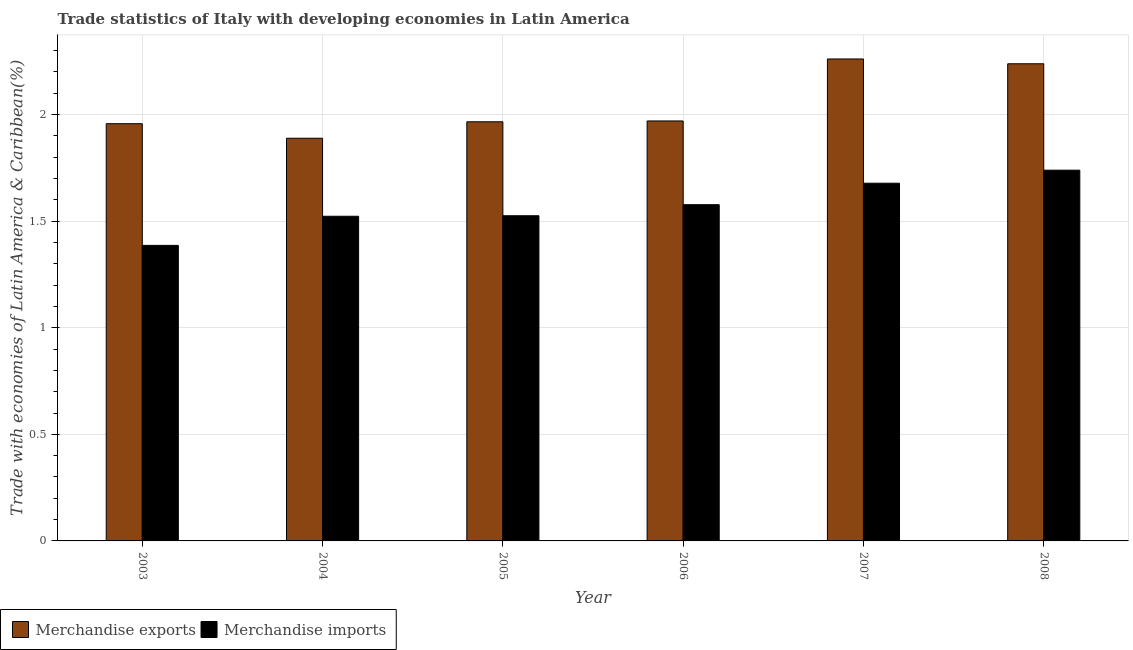How many different coloured bars are there?
Make the answer very short. 2. How many groups of bars are there?
Your response must be concise. 6. Are the number of bars on each tick of the X-axis equal?
Your response must be concise. Yes. How many bars are there on the 6th tick from the left?
Give a very brief answer. 2. What is the label of the 3rd group of bars from the left?
Keep it short and to the point. 2005. In how many cases, is the number of bars for a given year not equal to the number of legend labels?
Offer a terse response. 0. What is the merchandise exports in 2006?
Provide a short and direct response. 1.97. Across all years, what is the maximum merchandise exports?
Provide a short and direct response. 2.26. Across all years, what is the minimum merchandise imports?
Ensure brevity in your answer.  1.39. In which year was the merchandise imports minimum?
Provide a short and direct response. 2003. What is the total merchandise imports in the graph?
Make the answer very short. 9.43. What is the difference between the merchandise exports in 2003 and that in 2005?
Keep it short and to the point. -0.01. What is the difference between the merchandise exports in 2006 and the merchandise imports in 2007?
Provide a short and direct response. -0.29. What is the average merchandise exports per year?
Offer a very short reply. 2.05. In the year 2007, what is the difference between the merchandise exports and merchandise imports?
Provide a short and direct response. 0. What is the ratio of the merchandise imports in 2003 to that in 2004?
Provide a succinct answer. 0.91. Is the merchandise exports in 2003 less than that in 2008?
Offer a terse response. Yes. Is the difference between the merchandise exports in 2007 and 2008 greater than the difference between the merchandise imports in 2007 and 2008?
Offer a terse response. No. What is the difference between the highest and the second highest merchandise imports?
Offer a very short reply. 0.06. What is the difference between the highest and the lowest merchandise imports?
Keep it short and to the point. 0.35. Is the sum of the merchandise exports in 2004 and 2007 greater than the maximum merchandise imports across all years?
Make the answer very short. Yes. How many years are there in the graph?
Offer a very short reply. 6. Does the graph contain grids?
Your answer should be compact. Yes. How many legend labels are there?
Offer a terse response. 2. What is the title of the graph?
Provide a succinct answer. Trade statistics of Italy with developing economies in Latin America. What is the label or title of the X-axis?
Your answer should be compact. Year. What is the label or title of the Y-axis?
Give a very brief answer. Trade with economies of Latin America & Caribbean(%). What is the Trade with economies of Latin America & Caribbean(%) in Merchandise exports in 2003?
Keep it short and to the point. 1.96. What is the Trade with economies of Latin America & Caribbean(%) in Merchandise imports in 2003?
Your answer should be compact. 1.39. What is the Trade with economies of Latin America & Caribbean(%) in Merchandise exports in 2004?
Make the answer very short. 1.89. What is the Trade with economies of Latin America & Caribbean(%) of Merchandise imports in 2004?
Your response must be concise. 1.52. What is the Trade with economies of Latin America & Caribbean(%) in Merchandise exports in 2005?
Make the answer very short. 1.97. What is the Trade with economies of Latin America & Caribbean(%) of Merchandise imports in 2005?
Provide a short and direct response. 1.53. What is the Trade with economies of Latin America & Caribbean(%) in Merchandise exports in 2006?
Provide a short and direct response. 1.97. What is the Trade with economies of Latin America & Caribbean(%) in Merchandise imports in 2006?
Provide a succinct answer. 1.58. What is the Trade with economies of Latin America & Caribbean(%) in Merchandise exports in 2007?
Provide a short and direct response. 2.26. What is the Trade with economies of Latin America & Caribbean(%) of Merchandise imports in 2007?
Your response must be concise. 1.68. What is the Trade with economies of Latin America & Caribbean(%) of Merchandise exports in 2008?
Make the answer very short. 2.24. What is the Trade with economies of Latin America & Caribbean(%) of Merchandise imports in 2008?
Provide a short and direct response. 1.74. Across all years, what is the maximum Trade with economies of Latin America & Caribbean(%) in Merchandise exports?
Your response must be concise. 2.26. Across all years, what is the maximum Trade with economies of Latin America & Caribbean(%) in Merchandise imports?
Offer a terse response. 1.74. Across all years, what is the minimum Trade with economies of Latin America & Caribbean(%) in Merchandise exports?
Provide a succinct answer. 1.89. Across all years, what is the minimum Trade with economies of Latin America & Caribbean(%) of Merchandise imports?
Your response must be concise. 1.39. What is the total Trade with economies of Latin America & Caribbean(%) of Merchandise exports in the graph?
Give a very brief answer. 12.28. What is the total Trade with economies of Latin America & Caribbean(%) of Merchandise imports in the graph?
Offer a terse response. 9.43. What is the difference between the Trade with economies of Latin America & Caribbean(%) of Merchandise exports in 2003 and that in 2004?
Provide a short and direct response. 0.07. What is the difference between the Trade with economies of Latin America & Caribbean(%) in Merchandise imports in 2003 and that in 2004?
Keep it short and to the point. -0.14. What is the difference between the Trade with economies of Latin America & Caribbean(%) of Merchandise exports in 2003 and that in 2005?
Keep it short and to the point. -0.01. What is the difference between the Trade with economies of Latin America & Caribbean(%) of Merchandise imports in 2003 and that in 2005?
Offer a very short reply. -0.14. What is the difference between the Trade with economies of Latin America & Caribbean(%) in Merchandise exports in 2003 and that in 2006?
Provide a succinct answer. -0.01. What is the difference between the Trade with economies of Latin America & Caribbean(%) in Merchandise imports in 2003 and that in 2006?
Provide a short and direct response. -0.19. What is the difference between the Trade with economies of Latin America & Caribbean(%) of Merchandise exports in 2003 and that in 2007?
Your answer should be compact. -0.3. What is the difference between the Trade with economies of Latin America & Caribbean(%) in Merchandise imports in 2003 and that in 2007?
Give a very brief answer. -0.29. What is the difference between the Trade with economies of Latin America & Caribbean(%) in Merchandise exports in 2003 and that in 2008?
Your response must be concise. -0.28. What is the difference between the Trade with economies of Latin America & Caribbean(%) in Merchandise imports in 2003 and that in 2008?
Ensure brevity in your answer.  -0.35. What is the difference between the Trade with economies of Latin America & Caribbean(%) in Merchandise exports in 2004 and that in 2005?
Your response must be concise. -0.08. What is the difference between the Trade with economies of Latin America & Caribbean(%) of Merchandise imports in 2004 and that in 2005?
Offer a very short reply. -0. What is the difference between the Trade with economies of Latin America & Caribbean(%) of Merchandise exports in 2004 and that in 2006?
Make the answer very short. -0.08. What is the difference between the Trade with economies of Latin America & Caribbean(%) of Merchandise imports in 2004 and that in 2006?
Provide a succinct answer. -0.05. What is the difference between the Trade with economies of Latin America & Caribbean(%) of Merchandise exports in 2004 and that in 2007?
Your answer should be compact. -0.37. What is the difference between the Trade with economies of Latin America & Caribbean(%) in Merchandise imports in 2004 and that in 2007?
Provide a short and direct response. -0.15. What is the difference between the Trade with economies of Latin America & Caribbean(%) of Merchandise exports in 2004 and that in 2008?
Give a very brief answer. -0.35. What is the difference between the Trade with economies of Latin America & Caribbean(%) of Merchandise imports in 2004 and that in 2008?
Offer a terse response. -0.22. What is the difference between the Trade with economies of Latin America & Caribbean(%) in Merchandise exports in 2005 and that in 2006?
Your response must be concise. -0. What is the difference between the Trade with economies of Latin America & Caribbean(%) in Merchandise imports in 2005 and that in 2006?
Provide a short and direct response. -0.05. What is the difference between the Trade with economies of Latin America & Caribbean(%) of Merchandise exports in 2005 and that in 2007?
Provide a succinct answer. -0.29. What is the difference between the Trade with economies of Latin America & Caribbean(%) of Merchandise imports in 2005 and that in 2007?
Give a very brief answer. -0.15. What is the difference between the Trade with economies of Latin America & Caribbean(%) in Merchandise exports in 2005 and that in 2008?
Your answer should be compact. -0.27. What is the difference between the Trade with economies of Latin America & Caribbean(%) of Merchandise imports in 2005 and that in 2008?
Provide a short and direct response. -0.21. What is the difference between the Trade with economies of Latin America & Caribbean(%) in Merchandise exports in 2006 and that in 2007?
Offer a very short reply. -0.29. What is the difference between the Trade with economies of Latin America & Caribbean(%) in Merchandise imports in 2006 and that in 2007?
Make the answer very short. -0.1. What is the difference between the Trade with economies of Latin America & Caribbean(%) in Merchandise exports in 2006 and that in 2008?
Provide a short and direct response. -0.27. What is the difference between the Trade with economies of Latin America & Caribbean(%) in Merchandise imports in 2006 and that in 2008?
Give a very brief answer. -0.16. What is the difference between the Trade with economies of Latin America & Caribbean(%) in Merchandise exports in 2007 and that in 2008?
Your answer should be compact. 0.02. What is the difference between the Trade with economies of Latin America & Caribbean(%) in Merchandise imports in 2007 and that in 2008?
Give a very brief answer. -0.06. What is the difference between the Trade with economies of Latin America & Caribbean(%) of Merchandise exports in 2003 and the Trade with economies of Latin America & Caribbean(%) of Merchandise imports in 2004?
Your answer should be compact. 0.43. What is the difference between the Trade with economies of Latin America & Caribbean(%) of Merchandise exports in 2003 and the Trade with economies of Latin America & Caribbean(%) of Merchandise imports in 2005?
Keep it short and to the point. 0.43. What is the difference between the Trade with economies of Latin America & Caribbean(%) of Merchandise exports in 2003 and the Trade with economies of Latin America & Caribbean(%) of Merchandise imports in 2006?
Your response must be concise. 0.38. What is the difference between the Trade with economies of Latin America & Caribbean(%) of Merchandise exports in 2003 and the Trade with economies of Latin America & Caribbean(%) of Merchandise imports in 2007?
Keep it short and to the point. 0.28. What is the difference between the Trade with economies of Latin America & Caribbean(%) in Merchandise exports in 2003 and the Trade with economies of Latin America & Caribbean(%) in Merchandise imports in 2008?
Offer a very short reply. 0.22. What is the difference between the Trade with economies of Latin America & Caribbean(%) in Merchandise exports in 2004 and the Trade with economies of Latin America & Caribbean(%) in Merchandise imports in 2005?
Offer a very short reply. 0.36. What is the difference between the Trade with economies of Latin America & Caribbean(%) of Merchandise exports in 2004 and the Trade with economies of Latin America & Caribbean(%) of Merchandise imports in 2006?
Offer a very short reply. 0.31. What is the difference between the Trade with economies of Latin America & Caribbean(%) in Merchandise exports in 2004 and the Trade with economies of Latin America & Caribbean(%) in Merchandise imports in 2007?
Offer a terse response. 0.21. What is the difference between the Trade with economies of Latin America & Caribbean(%) in Merchandise exports in 2004 and the Trade with economies of Latin America & Caribbean(%) in Merchandise imports in 2008?
Give a very brief answer. 0.15. What is the difference between the Trade with economies of Latin America & Caribbean(%) in Merchandise exports in 2005 and the Trade with economies of Latin America & Caribbean(%) in Merchandise imports in 2006?
Your answer should be very brief. 0.39. What is the difference between the Trade with economies of Latin America & Caribbean(%) in Merchandise exports in 2005 and the Trade with economies of Latin America & Caribbean(%) in Merchandise imports in 2007?
Provide a succinct answer. 0.29. What is the difference between the Trade with economies of Latin America & Caribbean(%) of Merchandise exports in 2005 and the Trade with economies of Latin America & Caribbean(%) of Merchandise imports in 2008?
Offer a terse response. 0.23. What is the difference between the Trade with economies of Latin America & Caribbean(%) in Merchandise exports in 2006 and the Trade with economies of Latin America & Caribbean(%) in Merchandise imports in 2007?
Ensure brevity in your answer.  0.29. What is the difference between the Trade with economies of Latin America & Caribbean(%) of Merchandise exports in 2006 and the Trade with economies of Latin America & Caribbean(%) of Merchandise imports in 2008?
Your answer should be very brief. 0.23. What is the difference between the Trade with economies of Latin America & Caribbean(%) of Merchandise exports in 2007 and the Trade with economies of Latin America & Caribbean(%) of Merchandise imports in 2008?
Offer a terse response. 0.52. What is the average Trade with economies of Latin America & Caribbean(%) of Merchandise exports per year?
Offer a terse response. 2.05. What is the average Trade with economies of Latin America & Caribbean(%) of Merchandise imports per year?
Give a very brief answer. 1.57. In the year 2003, what is the difference between the Trade with economies of Latin America & Caribbean(%) of Merchandise exports and Trade with economies of Latin America & Caribbean(%) of Merchandise imports?
Provide a succinct answer. 0.57. In the year 2004, what is the difference between the Trade with economies of Latin America & Caribbean(%) in Merchandise exports and Trade with economies of Latin America & Caribbean(%) in Merchandise imports?
Ensure brevity in your answer.  0.37. In the year 2005, what is the difference between the Trade with economies of Latin America & Caribbean(%) of Merchandise exports and Trade with economies of Latin America & Caribbean(%) of Merchandise imports?
Make the answer very short. 0.44. In the year 2006, what is the difference between the Trade with economies of Latin America & Caribbean(%) of Merchandise exports and Trade with economies of Latin America & Caribbean(%) of Merchandise imports?
Your answer should be compact. 0.39. In the year 2007, what is the difference between the Trade with economies of Latin America & Caribbean(%) of Merchandise exports and Trade with economies of Latin America & Caribbean(%) of Merchandise imports?
Your answer should be very brief. 0.58. In the year 2008, what is the difference between the Trade with economies of Latin America & Caribbean(%) of Merchandise exports and Trade with economies of Latin America & Caribbean(%) of Merchandise imports?
Offer a very short reply. 0.5. What is the ratio of the Trade with economies of Latin America & Caribbean(%) of Merchandise exports in 2003 to that in 2004?
Keep it short and to the point. 1.04. What is the ratio of the Trade with economies of Latin America & Caribbean(%) in Merchandise imports in 2003 to that in 2004?
Give a very brief answer. 0.91. What is the ratio of the Trade with economies of Latin America & Caribbean(%) of Merchandise imports in 2003 to that in 2005?
Make the answer very short. 0.91. What is the ratio of the Trade with economies of Latin America & Caribbean(%) in Merchandise imports in 2003 to that in 2006?
Give a very brief answer. 0.88. What is the ratio of the Trade with economies of Latin America & Caribbean(%) of Merchandise exports in 2003 to that in 2007?
Keep it short and to the point. 0.87. What is the ratio of the Trade with economies of Latin America & Caribbean(%) of Merchandise imports in 2003 to that in 2007?
Your response must be concise. 0.83. What is the ratio of the Trade with economies of Latin America & Caribbean(%) in Merchandise exports in 2003 to that in 2008?
Your response must be concise. 0.87. What is the ratio of the Trade with economies of Latin America & Caribbean(%) of Merchandise imports in 2003 to that in 2008?
Make the answer very short. 0.8. What is the ratio of the Trade with economies of Latin America & Caribbean(%) in Merchandise exports in 2004 to that in 2005?
Offer a very short reply. 0.96. What is the ratio of the Trade with economies of Latin America & Caribbean(%) of Merchandise exports in 2004 to that in 2006?
Offer a terse response. 0.96. What is the ratio of the Trade with economies of Latin America & Caribbean(%) of Merchandise imports in 2004 to that in 2006?
Your answer should be compact. 0.97. What is the ratio of the Trade with economies of Latin America & Caribbean(%) in Merchandise exports in 2004 to that in 2007?
Provide a succinct answer. 0.84. What is the ratio of the Trade with economies of Latin America & Caribbean(%) of Merchandise imports in 2004 to that in 2007?
Offer a very short reply. 0.91. What is the ratio of the Trade with economies of Latin America & Caribbean(%) of Merchandise exports in 2004 to that in 2008?
Your answer should be very brief. 0.84. What is the ratio of the Trade with economies of Latin America & Caribbean(%) in Merchandise imports in 2004 to that in 2008?
Your answer should be very brief. 0.88. What is the ratio of the Trade with economies of Latin America & Caribbean(%) of Merchandise imports in 2005 to that in 2006?
Keep it short and to the point. 0.97. What is the ratio of the Trade with economies of Latin America & Caribbean(%) in Merchandise exports in 2005 to that in 2007?
Offer a very short reply. 0.87. What is the ratio of the Trade with economies of Latin America & Caribbean(%) in Merchandise imports in 2005 to that in 2007?
Offer a terse response. 0.91. What is the ratio of the Trade with economies of Latin America & Caribbean(%) of Merchandise exports in 2005 to that in 2008?
Make the answer very short. 0.88. What is the ratio of the Trade with economies of Latin America & Caribbean(%) in Merchandise imports in 2005 to that in 2008?
Offer a very short reply. 0.88. What is the ratio of the Trade with economies of Latin America & Caribbean(%) in Merchandise exports in 2006 to that in 2007?
Provide a short and direct response. 0.87. What is the ratio of the Trade with economies of Latin America & Caribbean(%) in Merchandise imports in 2006 to that in 2007?
Make the answer very short. 0.94. What is the ratio of the Trade with economies of Latin America & Caribbean(%) in Merchandise exports in 2006 to that in 2008?
Your response must be concise. 0.88. What is the ratio of the Trade with economies of Latin America & Caribbean(%) in Merchandise imports in 2006 to that in 2008?
Offer a very short reply. 0.91. What is the ratio of the Trade with economies of Latin America & Caribbean(%) in Merchandise imports in 2007 to that in 2008?
Offer a terse response. 0.96. What is the difference between the highest and the second highest Trade with economies of Latin America & Caribbean(%) of Merchandise exports?
Offer a very short reply. 0.02. What is the difference between the highest and the second highest Trade with economies of Latin America & Caribbean(%) in Merchandise imports?
Offer a very short reply. 0.06. What is the difference between the highest and the lowest Trade with economies of Latin America & Caribbean(%) in Merchandise exports?
Your answer should be very brief. 0.37. What is the difference between the highest and the lowest Trade with economies of Latin America & Caribbean(%) in Merchandise imports?
Your answer should be very brief. 0.35. 